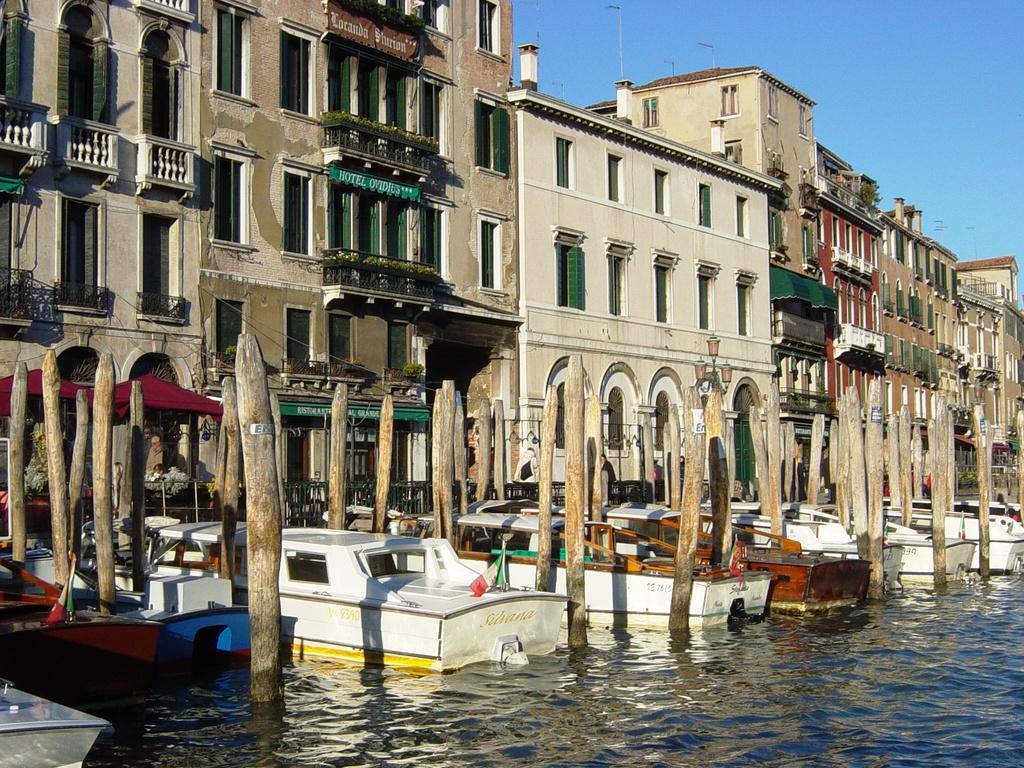What is in the water in the image? There are boats in the water in the image. What else can be seen in the image besides the boats? There are buildings visible in the image. What is visible at the top of the image? The sky is visible at the top of the image. What type of class is being taught in the image? There is no class or teaching activity present in the image. What territory is depicted in the image? The image does not depict a specific territory; it shows boats in the water and buildings. 